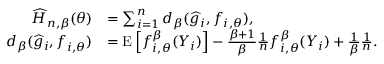Convert formula to latex. <formula><loc_0><loc_0><loc_500><loc_500>\begin{array} { r l } { \widehat { H } _ { n , \beta } ( \theta ) } & { = \sum _ { i = 1 } ^ { n } d _ { \beta } ( \widehat { g } _ { i } , f _ { i , \theta } ) , } \\ { d _ { \beta } ( \widehat { g } _ { i } , f _ { i , \theta } ) } & { = E \left [ f _ { i , \theta } ^ { \beta } ( Y _ { i } ) \right ] - \frac { \beta + 1 } { \beta } \frac { 1 } { n } f _ { i , \theta } ^ { \beta } ( Y _ { i } ) + \frac { 1 } { \beta } \frac { 1 } { n } . } \end{array}</formula> 